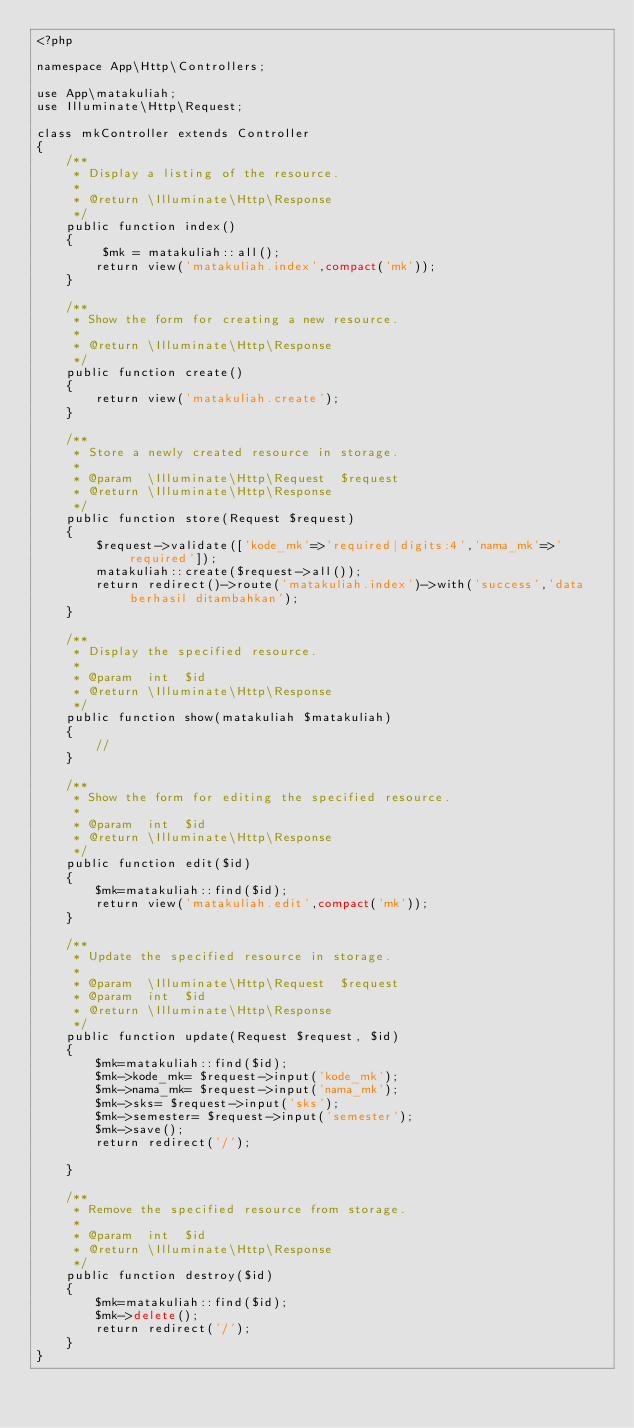<code> <loc_0><loc_0><loc_500><loc_500><_PHP_><?php

namespace App\Http\Controllers;

use App\matakuliah;
use Illuminate\Http\Request;

class mkController extends Controller
{
    /**
     * Display a listing of the resource.
     *
     * @return \Illuminate\Http\Response
     */
    public function index()
    {
         $mk = matakuliah::all();
        return view('matakuliah.index',compact('mk'));
    }

    /**
     * Show the form for creating a new resource.
     *
     * @return \Illuminate\Http\Response
     */
    public function create()
    {
        return view('matakuliah.create');
    }

    /**
     * Store a newly created resource in storage.
     *
     * @param  \Illuminate\Http\Request  $request
     * @return \Illuminate\Http\Response
     */
    public function store(Request $request)
    {
        $request->validate(['kode_mk'=>'required|digits:4','nama_mk'=>'required']);
        matakuliah::create($request->all());
        return redirect()->route('matakuliah.index')->with('success','data berhasil ditambahkan');
    }

    /**
     * Display the specified resource.
     *
     * @param  int  $id
     * @return \Illuminate\Http\Response
     */
    public function show(matakuliah $matakuliah)
    {
        //
    }

    /**
     * Show the form for editing the specified resource.
     *
     * @param  int  $id
     * @return \Illuminate\Http\Response
     */
    public function edit($id)
    {
        $mk=matakuliah::find($id);
        return view('matakuliah.edit',compact('mk'));
    }

    /**
     * Update the specified resource in storage.
     *
     * @param  \Illuminate\Http\Request  $request
     * @param  int  $id
     * @return \Illuminate\Http\Response
     */
    public function update(Request $request, $id)
    {
        $mk=matakuliah::find($id);
        $mk->kode_mk= $request->input('kode_mk');
        $mk->nama_mk= $request->input('nama_mk');
        $mk->sks= $request->input('sks');
        $mk->semester= $request->input('semester');
        $mk->save();
        return redirect('/');
        
    }

    /**
     * Remove the specified resource from storage.
     *
     * @param  int  $id
     * @return \Illuminate\Http\Response
     */
    public function destroy($id)
    {
        $mk=matakuliah::find($id);
        $mk->delete();
        return redirect('/');
    }
}
</code> 